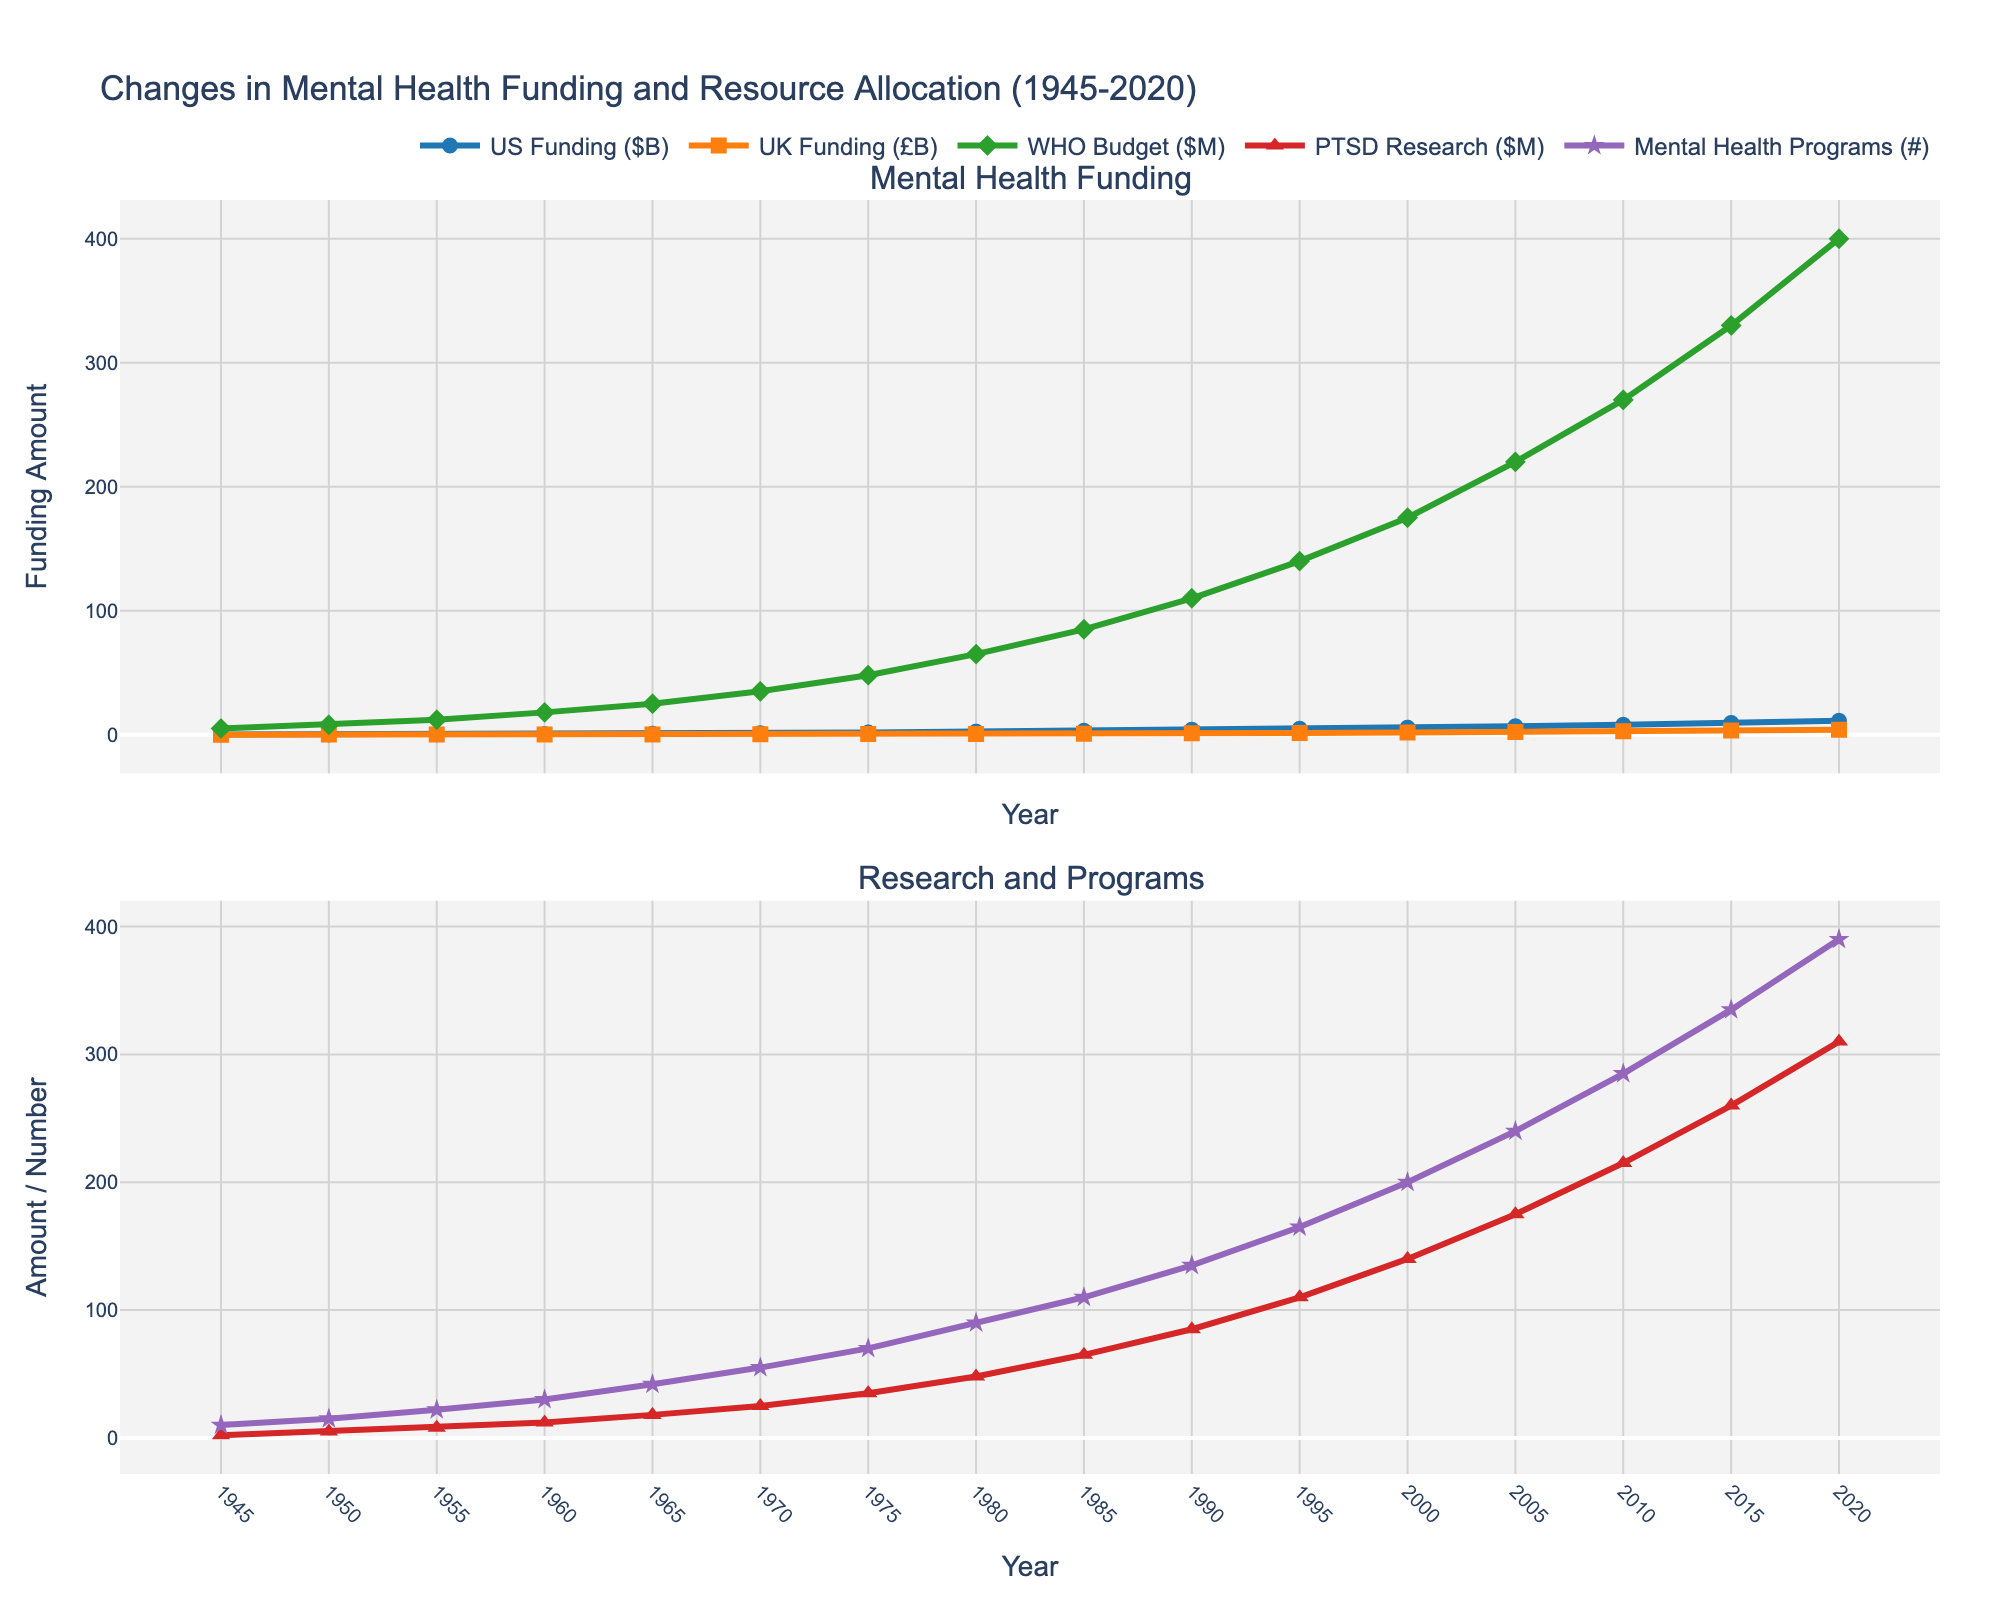What year saw the highest value for Conflict-Related Mental Health Programs? By observing the second subplot and looking at the line for the "Mental Health Programs (#)" which represents Conflict-Related Mental Health Programs, we see the highest point in 2020.
Answer: 2020 Which country, the US or the UK, had a higher increase in mental health funding from 2000 to 2020? First, refer to the funding data in the first subplot. In 2000, the US had $5.7B and the UK £1.75B. By 2020, the US increased to $11.2B and the UK to £4.00B. Calculate the differences: US = $11.2B - $5.7B = $5.5B; UK = £4.00B - £1.75B = £2.25B. The US showed a greater increase ($5.5B > £2.25B).
Answer: US In what year did PTSD Research Allocation first exceed $200 million? Check the second subplot for the "PTSD Research ($M)" line. It crosses $200M between 2005 and 2010. Specifically, by 2010 it reaches $215M.
Answer: 2010 What is the total number of Conflict-Related Mental Health Programs in 1980 and 1990 combined? Look at the second subplot to find the values for Conflict-Related Mental Health Programs in 1980 and 1990, which are 90 and 135 respectively. Sum them: 90 + 135 = 225.
Answer: 225 Has the WHO Global Mental Health Budget ($M) consistently increased over the entire period? In the first subplot, observe the "WHO Budget ($M)" line. The values increase steadily from the start (5 in 1945) to the end (400 in 2020), without any visible decreases.
Answer: Yes Which funding source saw the steepest increase between any two consecutive data points between 1960 and 2020? We need to check funding lines from 1960 to 2020 in the first subplot.
- US: $0.5B (1960) to $0.8B (1965) = $0.3B; (% increase)
- UK: £0.18B (1960) to £0.25B (1965) = £0.07B; (% increase)
- WHO: $18M (1960) to $25M (1965) = $7M; (% increase)
Other periods (1970-2015) reviewed similarly.
The steepest increase occurred for WHO from 2015 to 2020, calculated as $70M ($330M to $400M).
Answer: WHO Global Mental Health Budget from 2015 to 2020 By how much did the UK Mental Health Funding (£B) increase between 1945 and 2020? Check the data points in the first subplot at 1945 (0.05) and 2020 (4.00). Calculate the difference: £4.00B - £0.05B = £3.95B.
Answer: £3.95B Which type of funding or allocation reached exactly 100 units first within the time period, and in what year? Check all lines across both subplots for the first instance of hitting 100.
- US Funding: Exceeds 100 with $1.2B in 1970.
- UK Funding: Does not apply.
- WHO Budget: Reached 110M in 1990.
- PTSD Research: Reaches $110M by 1995.
- Programs: Registers 135 by 1990.
The earliest to precisely hit 100 is WHO in 1990.
Answer: WHO Global Mental Health Budget in 1990 